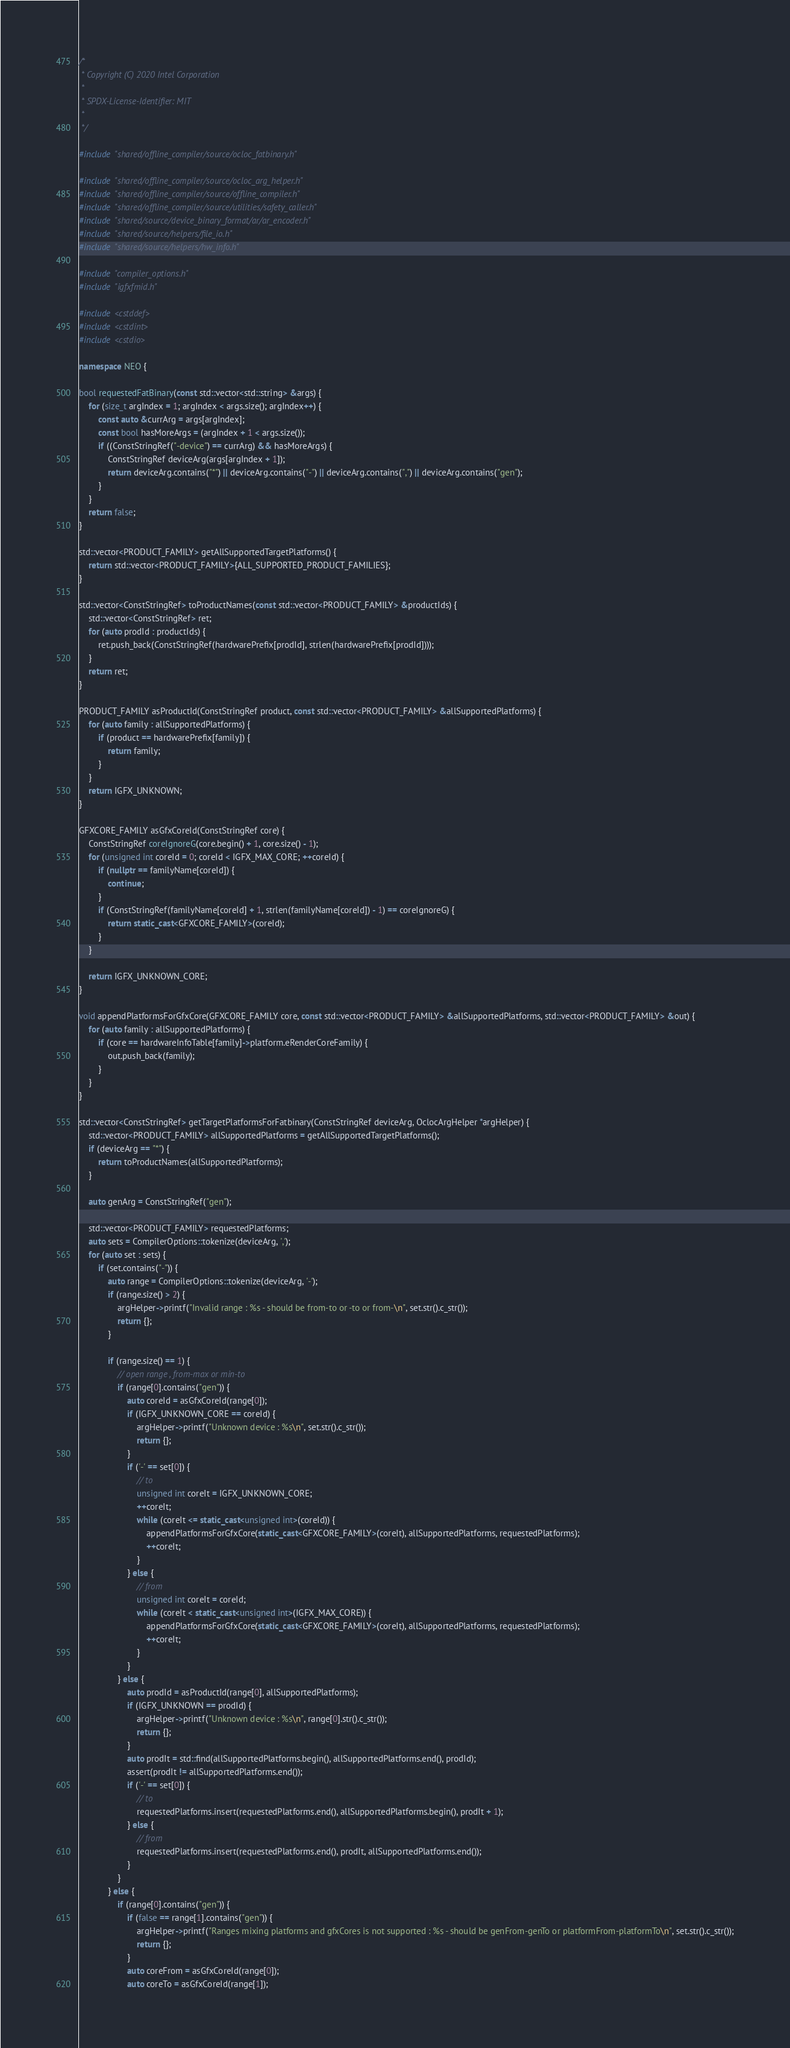<code> <loc_0><loc_0><loc_500><loc_500><_C++_>/*
 * Copyright (C) 2020 Intel Corporation
 *
 * SPDX-License-Identifier: MIT
 *
 */

#include "shared/offline_compiler/source/ocloc_fatbinary.h"

#include "shared/offline_compiler/source/ocloc_arg_helper.h"
#include "shared/offline_compiler/source/offline_compiler.h"
#include "shared/offline_compiler/source/utilities/safety_caller.h"
#include "shared/source/device_binary_format/ar/ar_encoder.h"
#include "shared/source/helpers/file_io.h"
#include "shared/source/helpers/hw_info.h"

#include "compiler_options.h"
#include "igfxfmid.h"

#include <cstddef>
#include <cstdint>
#include <cstdio>

namespace NEO {

bool requestedFatBinary(const std::vector<std::string> &args) {
    for (size_t argIndex = 1; argIndex < args.size(); argIndex++) {
        const auto &currArg = args[argIndex];
        const bool hasMoreArgs = (argIndex + 1 < args.size());
        if ((ConstStringRef("-device") == currArg) && hasMoreArgs) {
            ConstStringRef deviceArg(args[argIndex + 1]);
            return deviceArg.contains("*") || deviceArg.contains("-") || deviceArg.contains(",") || deviceArg.contains("gen");
        }
    }
    return false;
}

std::vector<PRODUCT_FAMILY> getAllSupportedTargetPlatforms() {
    return std::vector<PRODUCT_FAMILY>{ALL_SUPPORTED_PRODUCT_FAMILIES};
}

std::vector<ConstStringRef> toProductNames(const std::vector<PRODUCT_FAMILY> &productIds) {
    std::vector<ConstStringRef> ret;
    for (auto prodId : productIds) {
        ret.push_back(ConstStringRef(hardwarePrefix[prodId], strlen(hardwarePrefix[prodId])));
    }
    return ret;
}

PRODUCT_FAMILY asProductId(ConstStringRef product, const std::vector<PRODUCT_FAMILY> &allSupportedPlatforms) {
    for (auto family : allSupportedPlatforms) {
        if (product == hardwarePrefix[family]) {
            return family;
        }
    }
    return IGFX_UNKNOWN;
}

GFXCORE_FAMILY asGfxCoreId(ConstStringRef core) {
    ConstStringRef coreIgnoreG(core.begin() + 1, core.size() - 1);
    for (unsigned int coreId = 0; coreId < IGFX_MAX_CORE; ++coreId) {
        if (nullptr == familyName[coreId]) {
            continue;
        }
        if (ConstStringRef(familyName[coreId] + 1, strlen(familyName[coreId]) - 1) == coreIgnoreG) {
            return static_cast<GFXCORE_FAMILY>(coreId);
        }
    }

    return IGFX_UNKNOWN_CORE;
}

void appendPlatformsForGfxCore(GFXCORE_FAMILY core, const std::vector<PRODUCT_FAMILY> &allSupportedPlatforms, std::vector<PRODUCT_FAMILY> &out) {
    for (auto family : allSupportedPlatforms) {
        if (core == hardwareInfoTable[family]->platform.eRenderCoreFamily) {
            out.push_back(family);
        }
    }
}

std::vector<ConstStringRef> getTargetPlatformsForFatbinary(ConstStringRef deviceArg, OclocArgHelper *argHelper) {
    std::vector<PRODUCT_FAMILY> allSupportedPlatforms = getAllSupportedTargetPlatforms();
    if (deviceArg == "*") {
        return toProductNames(allSupportedPlatforms);
    }

    auto genArg = ConstStringRef("gen");

    std::vector<PRODUCT_FAMILY> requestedPlatforms;
    auto sets = CompilerOptions::tokenize(deviceArg, ',');
    for (auto set : sets) {
        if (set.contains("-")) {
            auto range = CompilerOptions::tokenize(deviceArg, '-');
            if (range.size() > 2) {
                argHelper->printf("Invalid range : %s - should be from-to or -to or from-\n", set.str().c_str());
                return {};
            }

            if (range.size() == 1) {
                // open range , from-max or min-to
                if (range[0].contains("gen")) {
                    auto coreId = asGfxCoreId(range[0]);
                    if (IGFX_UNKNOWN_CORE == coreId) {
                        argHelper->printf("Unknown device : %s\n", set.str().c_str());
                        return {};
                    }
                    if ('-' == set[0]) {
                        // to
                        unsigned int coreIt = IGFX_UNKNOWN_CORE;
                        ++coreIt;
                        while (coreIt <= static_cast<unsigned int>(coreId)) {
                            appendPlatformsForGfxCore(static_cast<GFXCORE_FAMILY>(coreIt), allSupportedPlatforms, requestedPlatforms);
                            ++coreIt;
                        }
                    } else {
                        // from
                        unsigned int coreIt = coreId;
                        while (coreIt < static_cast<unsigned int>(IGFX_MAX_CORE)) {
                            appendPlatformsForGfxCore(static_cast<GFXCORE_FAMILY>(coreIt), allSupportedPlatforms, requestedPlatforms);
                            ++coreIt;
                        }
                    }
                } else {
                    auto prodId = asProductId(range[0], allSupportedPlatforms);
                    if (IGFX_UNKNOWN == prodId) {
                        argHelper->printf("Unknown device : %s\n", range[0].str().c_str());
                        return {};
                    }
                    auto prodIt = std::find(allSupportedPlatforms.begin(), allSupportedPlatforms.end(), prodId);
                    assert(prodIt != allSupportedPlatforms.end());
                    if ('-' == set[0]) {
                        // to
                        requestedPlatforms.insert(requestedPlatforms.end(), allSupportedPlatforms.begin(), prodIt + 1);
                    } else {
                        // from
                        requestedPlatforms.insert(requestedPlatforms.end(), prodIt, allSupportedPlatforms.end());
                    }
                }
            } else {
                if (range[0].contains("gen")) {
                    if (false == range[1].contains("gen")) {
                        argHelper->printf("Ranges mixing platforms and gfxCores is not supported : %s - should be genFrom-genTo or platformFrom-platformTo\n", set.str().c_str());
                        return {};
                    }
                    auto coreFrom = asGfxCoreId(range[0]);
                    auto coreTo = asGfxCoreId(range[1]);</code> 